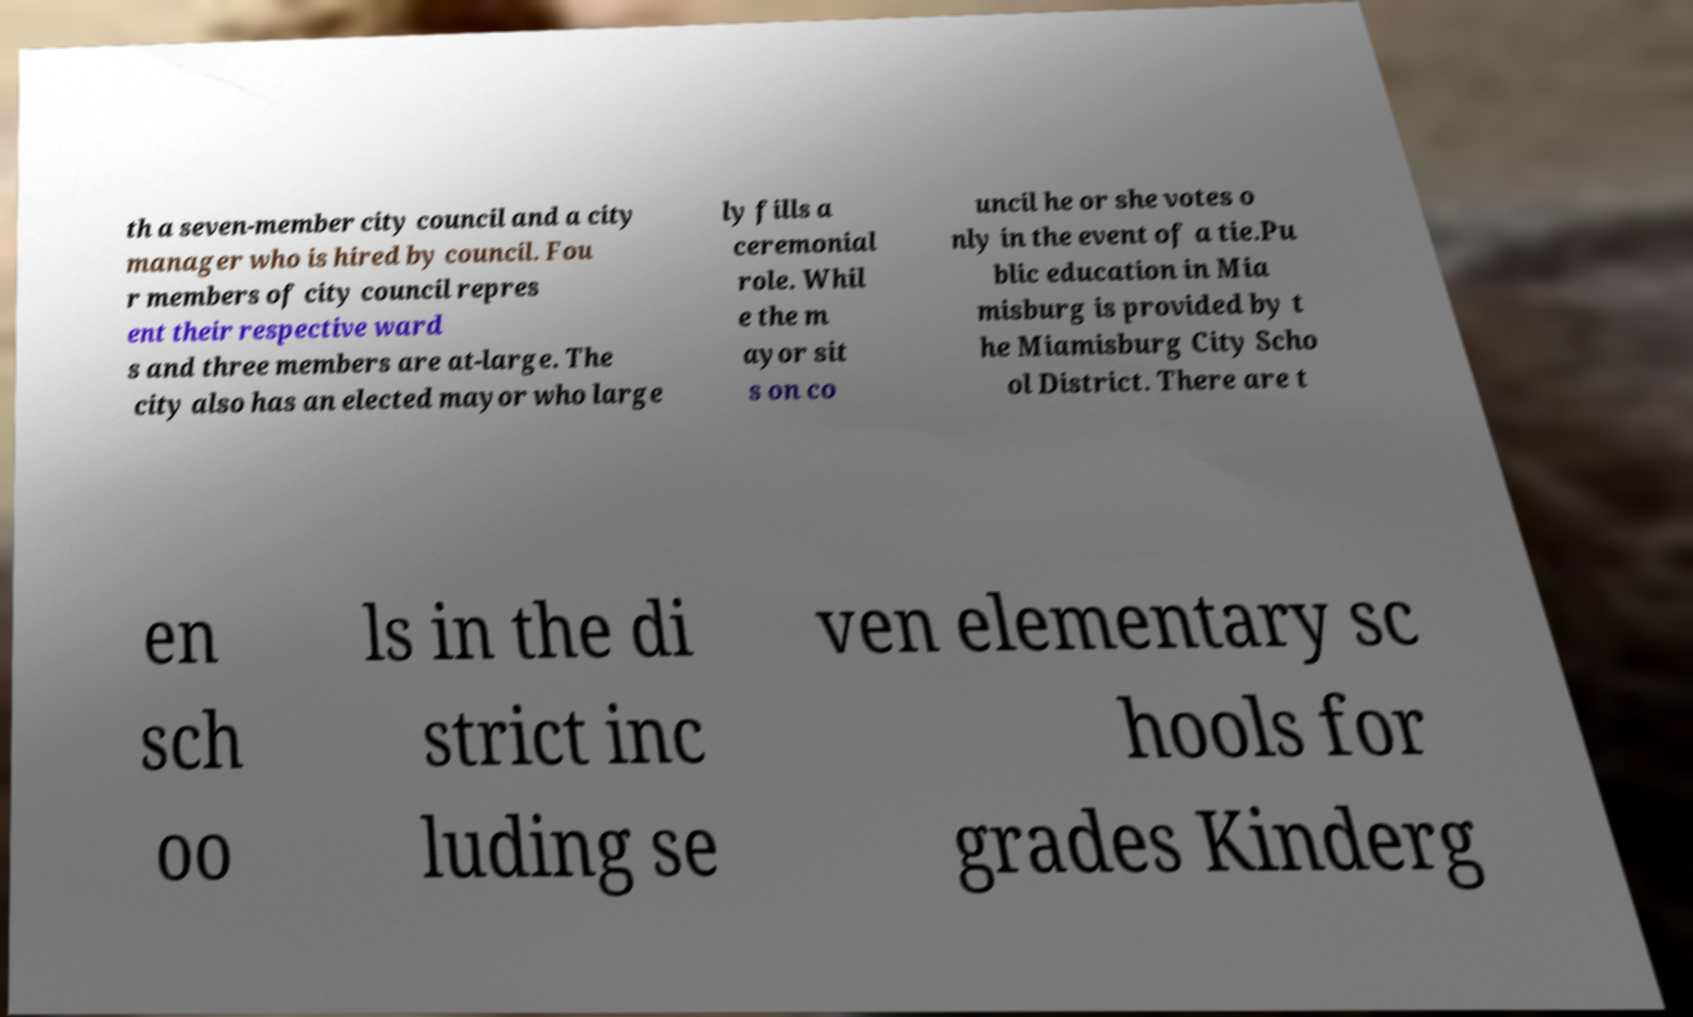For documentation purposes, I need the text within this image transcribed. Could you provide that? th a seven-member city council and a city manager who is hired by council. Fou r members of city council repres ent their respective ward s and three members are at-large. The city also has an elected mayor who large ly fills a ceremonial role. Whil e the m ayor sit s on co uncil he or she votes o nly in the event of a tie.Pu blic education in Mia misburg is provided by t he Miamisburg City Scho ol District. There are t en sch oo ls in the di strict inc luding se ven elementary sc hools for grades Kinderg 